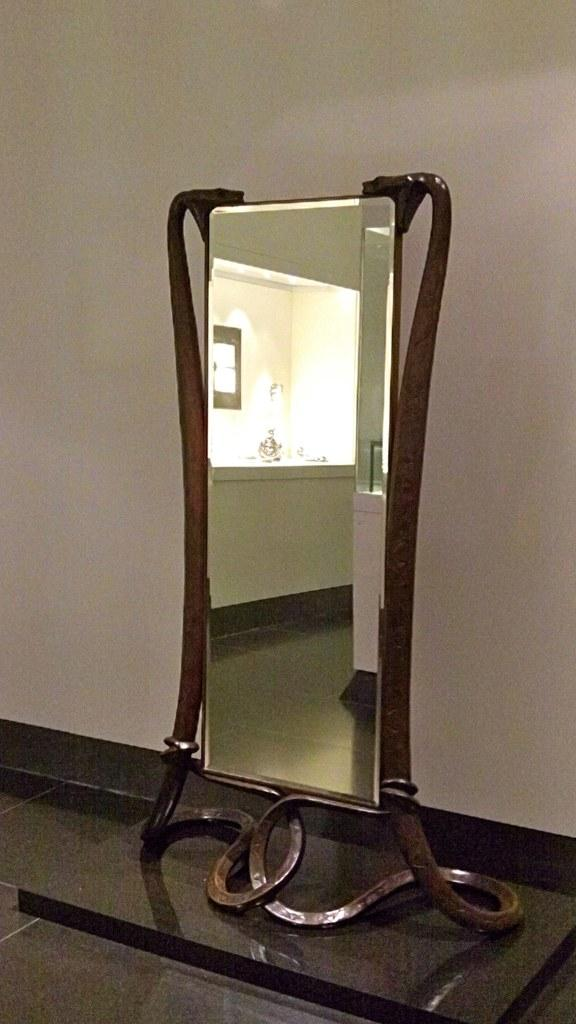What object is present in the image that can be used for reflecting? There is a mirror in the image. What surrounds the mirror in the image? There is a frame in the image. What can be seen behind the mirror and frame in the image? There is a wall in the background of the image. What type of potato is being used as a decoration in the image? There is no potato present in the image; it only features a mirror, frame, and wall. 